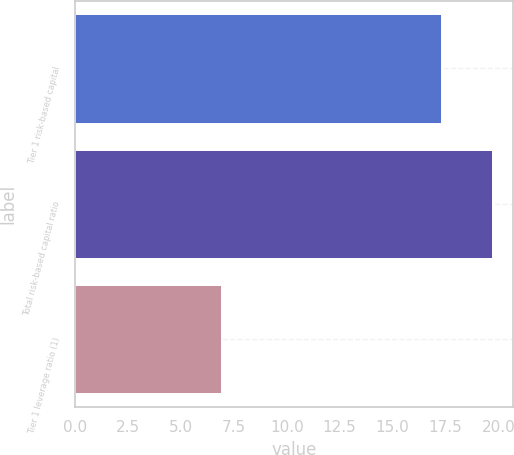Convert chart to OTSL. <chart><loc_0><loc_0><loc_500><loc_500><bar_chart><fcel>Tier 1 risk-based capital<fcel>Total risk-based capital ratio<fcel>Tier 1 leverage ratio (1)<nl><fcel>17.3<fcel>19.7<fcel>6.9<nl></chart> 